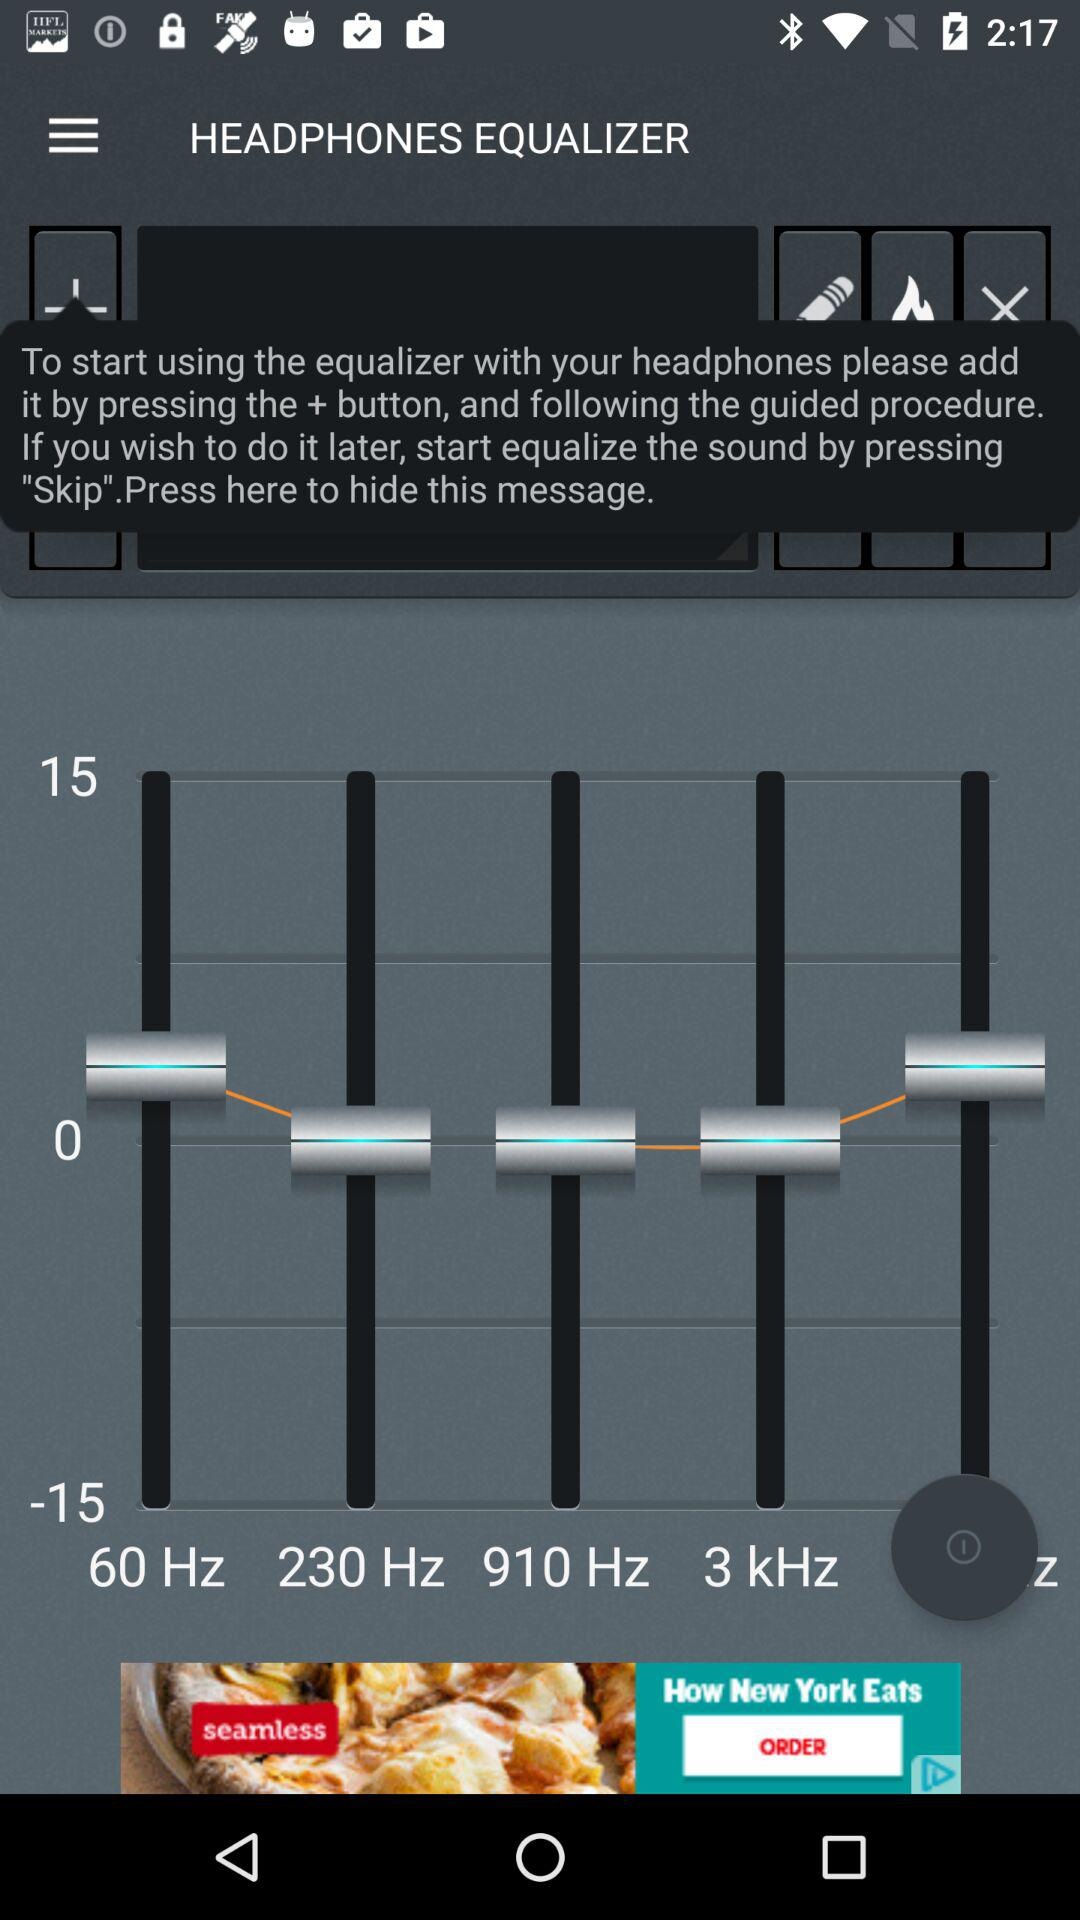What is the application name? The application name is "HEADPHONES EQUALIZER". 